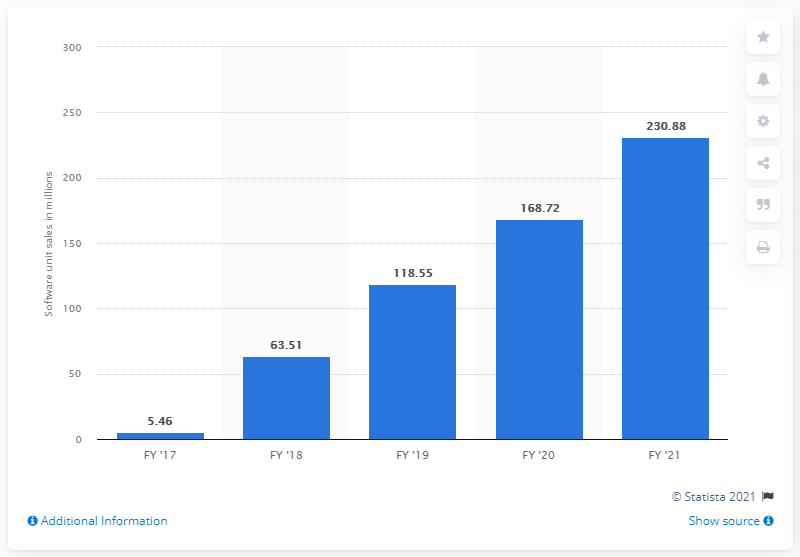Draw attention to some important aspects in this diagram. Nintendo sold 230,880 units of software in the fiscal year ending March 2021. 